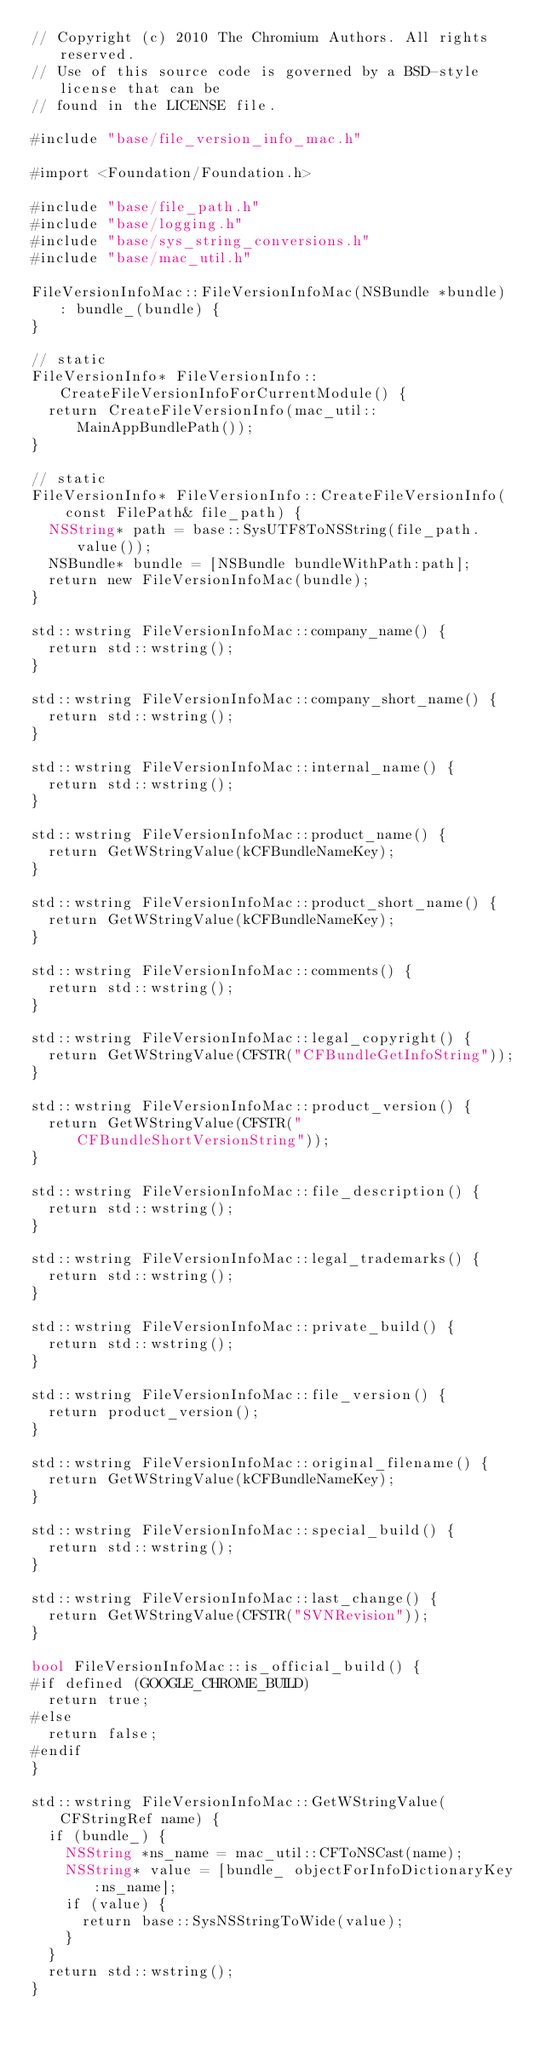Convert code to text. <code><loc_0><loc_0><loc_500><loc_500><_ObjectiveC_>// Copyright (c) 2010 The Chromium Authors. All rights reserved.
// Use of this source code is governed by a BSD-style license that can be
// found in the LICENSE file.

#include "base/file_version_info_mac.h"

#import <Foundation/Foundation.h>

#include "base/file_path.h"
#include "base/logging.h"
#include "base/sys_string_conversions.h"
#include "base/mac_util.h"

FileVersionInfoMac::FileVersionInfoMac(NSBundle *bundle) : bundle_(bundle) {
}

// static
FileVersionInfo* FileVersionInfo::CreateFileVersionInfoForCurrentModule() {
  return CreateFileVersionInfo(mac_util::MainAppBundlePath());
}

// static
FileVersionInfo* FileVersionInfo::CreateFileVersionInfo(
    const FilePath& file_path) {
  NSString* path = base::SysUTF8ToNSString(file_path.value());
  NSBundle* bundle = [NSBundle bundleWithPath:path];
  return new FileVersionInfoMac(bundle);
}

std::wstring FileVersionInfoMac::company_name() {
  return std::wstring();
}

std::wstring FileVersionInfoMac::company_short_name() {
  return std::wstring();
}

std::wstring FileVersionInfoMac::internal_name() {
  return std::wstring();
}

std::wstring FileVersionInfoMac::product_name() {
  return GetWStringValue(kCFBundleNameKey);
}

std::wstring FileVersionInfoMac::product_short_name() {
  return GetWStringValue(kCFBundleNameKey);
}

std::wstring FileVersionInfoMac::comments() {
  return std::wstring();
}

std::wstring FileVersionInfoMac::legal_copyright() {
  return GetWStringValue(CFSTR("CFBundleGetInfoString"));
}

std::wstring FileVersionInfoMac::product_version() {
  return GetWStringValue(CFSTR("CFBundleShortVersionString"));
}

std::wstring FileVersionInfoMac::file_description() {
  return std::wstring();
}

std::wstring FileVersionInfoMac::legal_trademarks() {
  return std::wstring();
}

std::wstring FileVersionInfoMac::private_build() {
  return std::wstring();
}

std::wstring FileVersionInfoMac::file_version() {
  return product_version();
}

std::wstring FileVersionInfoMac::original_filename() {
  return GetWStringValue(kCFBundleNameKey);
}

std::wstring FileVersionInfoMac::special_build() {
  return std::wstring();
}

std::wstring FileVersionInfoMac::last_change() {
  return GetWStringValue(CFSTR("SVNRevision"));
}

bool FileVersionInfoMac::is_official_build() {
#if defined (GOOGLE_CHROME_BUILD)
  return true;
#else
  return false;
#endif
}

std::wstring FileVersionInfoMac::GetWStringValue(CFStringRef name) {
  if (bundle_) {
    NSString *ns_name = mac_util::CFToNSCast(name);
    NSString* value = [bundle_ objectForInfoDictionaryKey:ns_name];
    if (value) {
      return base::SysNSStringToWide(value);
    }
  }
  return std::wstring();
}
</code> 